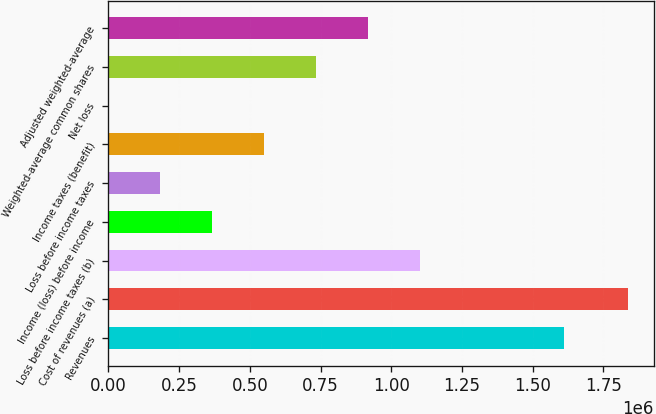<chart> <loc_0><loc_0><loc_500><loc_500><bar_chart><fcel>Revenues<fcel>Cost of revenues (a)<fcel>Loss before income taxes (b)<fcel>Income (loss) before income<fcel>Loss before income taxes<fcel>Income taxes (benefit)<fcel>Net loss<fcel>Weighted-average common shares<fcel>Adjusted weighted-average<nl><fcel>1.61167e+06<fcel>1.83681e+06<fcel>1.10209e+06<fcel>367363<fcel>183682<fcel>551044<fcel>1.33<fcel>734724<fcel>918405<nl></chart> 